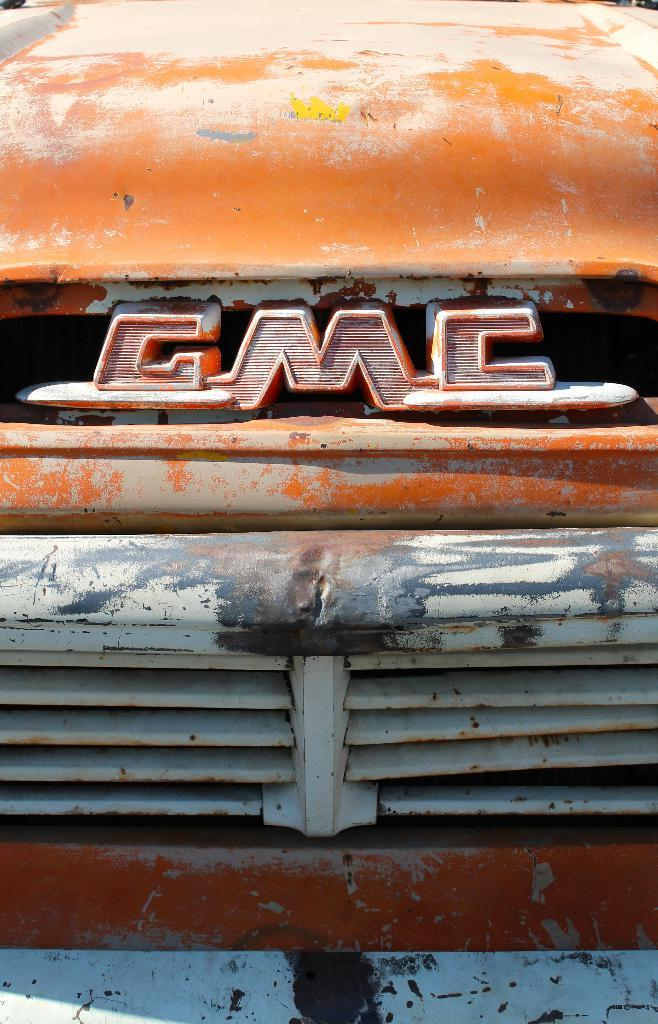What is the main subject of the image? The main subject of the image is a car. Can you describe the car in the image? The image is a zoomed-in picture of a car, so we can only see a portion of the car in detail. What type of land can be seen in the background of the image? There is no land visible in the image, as it is a zoomed-in picture of a car. What kind of feast is being prepared in the car? There is no feast or any indication of food preparation in the image; it is a picture of a car. 